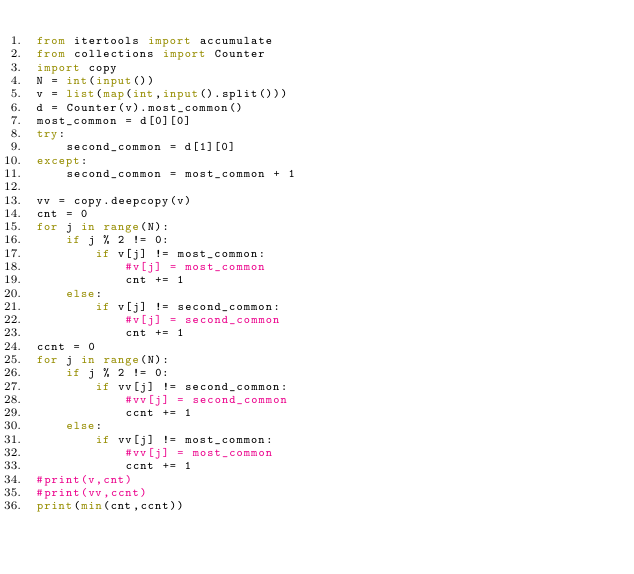Convert code to text. <code><loc_0><loc_0><loc_500><loc_500><_Python_>from itertools import accumulate
from collections import Counter
import copy
N = int(input())
v = list(map(int,input().split()))
d = Counter(v).most_common()
most_common = d[0][0]
try:
    second_common = d[1][0]
except:
    second_common = most_common + 1

vv = copy.deepcopy(v)
cnt = 0
for j in range(N):
    if j % 2 != 0:
        if v[j] != most_common:
            #v[j] = most_common
            cnt += 1
    else:
        if v[j] != second_common:
            #v[j] = second_common
            cnt += 1
ccnt = 0
for j in range(N):
    if j % 2 != 0:
        if vv[j] != second_common:
            #vv[j] = second_common
            ccnt += 1
    else:
        if vv[j] != most_common:
            #vv[j] = most_common
            ccnt += 1
#print(v,cnt)
#print(vv,ccnt)
print(min(cnt,ccnt))</code> 